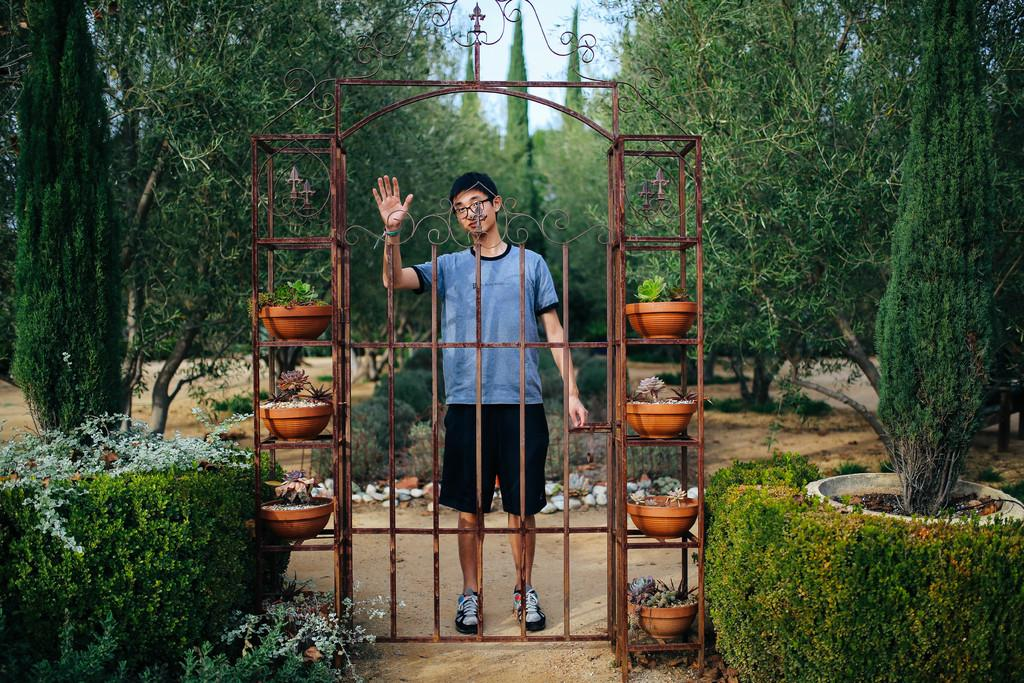What type of living organisms can be seen in the image? Plants can be seen in the image. What type of structure is present in the image? There is a gate and a house in the image. How are the plants arranged in the image? Plants are on grills in the image. What is the man in the image doing? There is a man standing in the image. What can be seen in the background of the image? Trees, plants, and the sky are visible in the background of the image. What type of feeling does the end of the offer convey in the image? There is no mention of an offer or any feelings in the image; it features plants, a gate, a house, a man, and various background elements. 